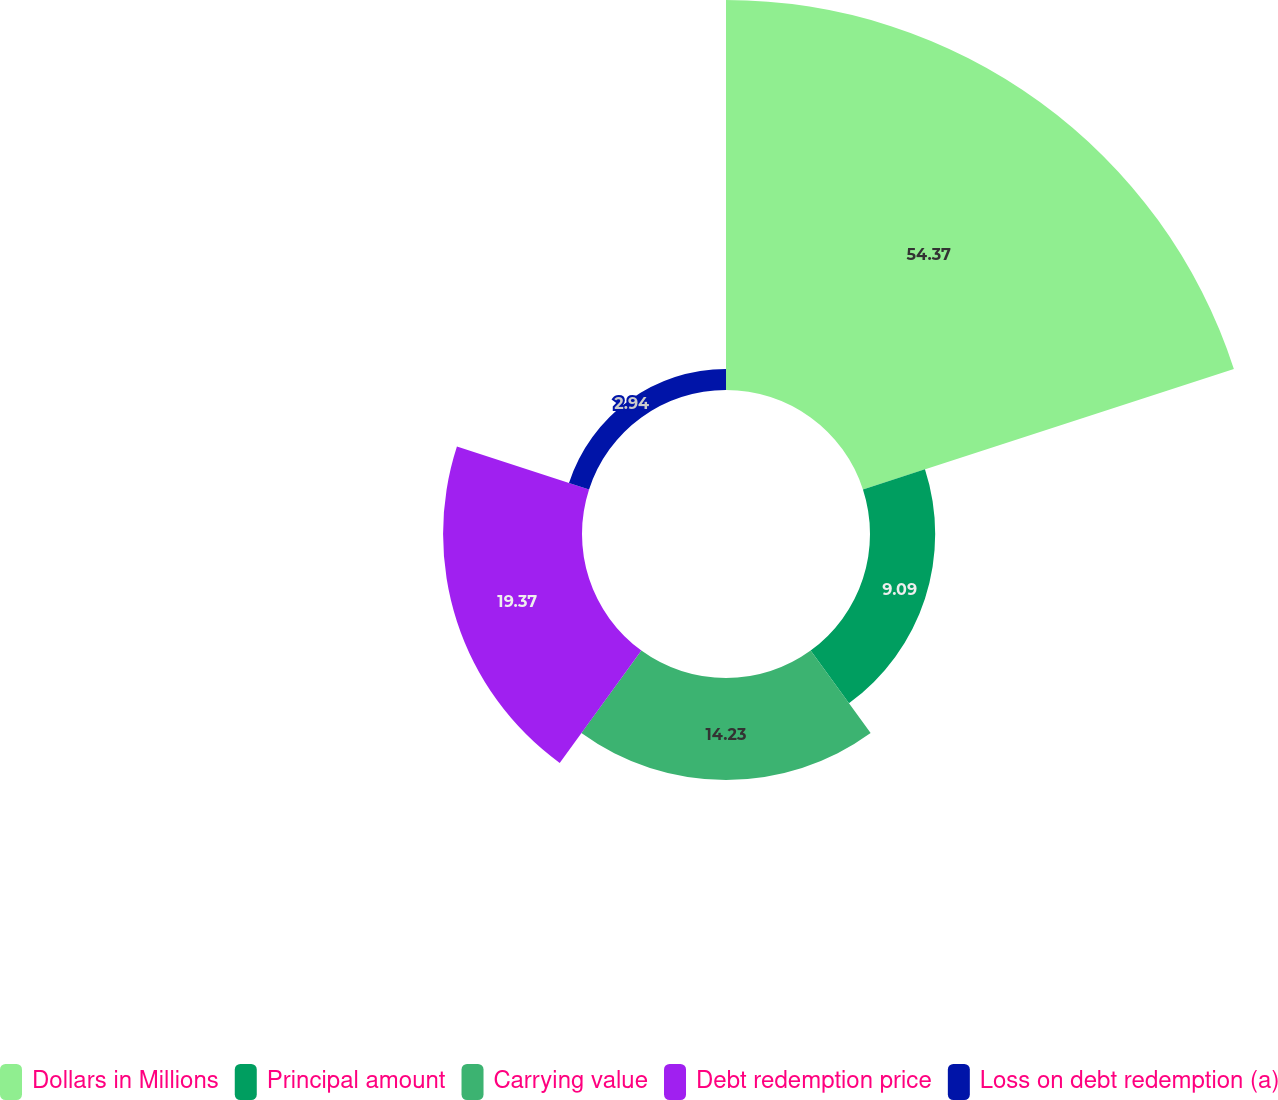Convert chart. <chart><loc_0><loc_0><loc_500><loc_500><pie_chart><fcel>Dollars in Millions<fcel>Principal amount<fcel>Carrying value<fcel>Debt redemption price<fcel>Loss on debt redemption (a)<nl><fcel>54.38%<fcel>9.09%<fcel>14.23%<fcel>19.37%<fcel>2.94%<nl></chart> 